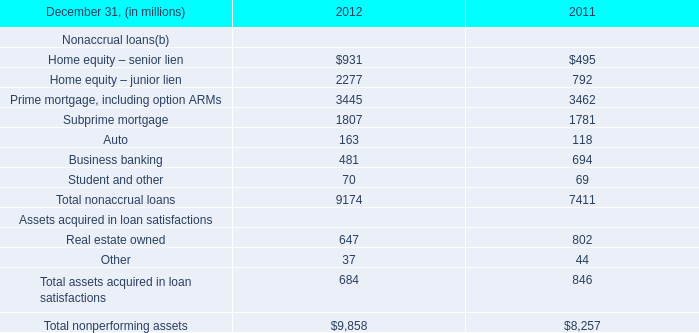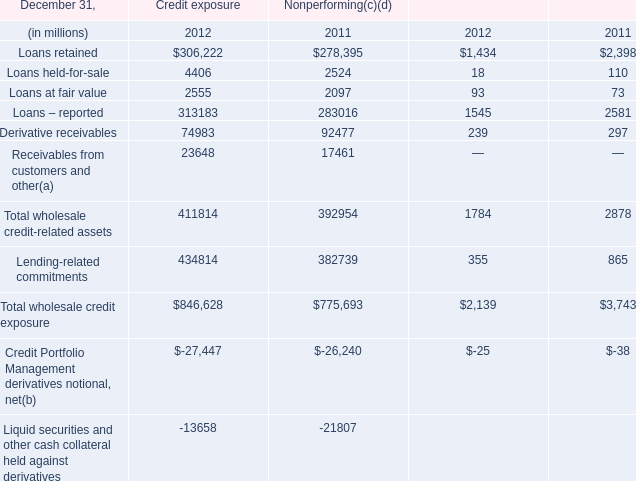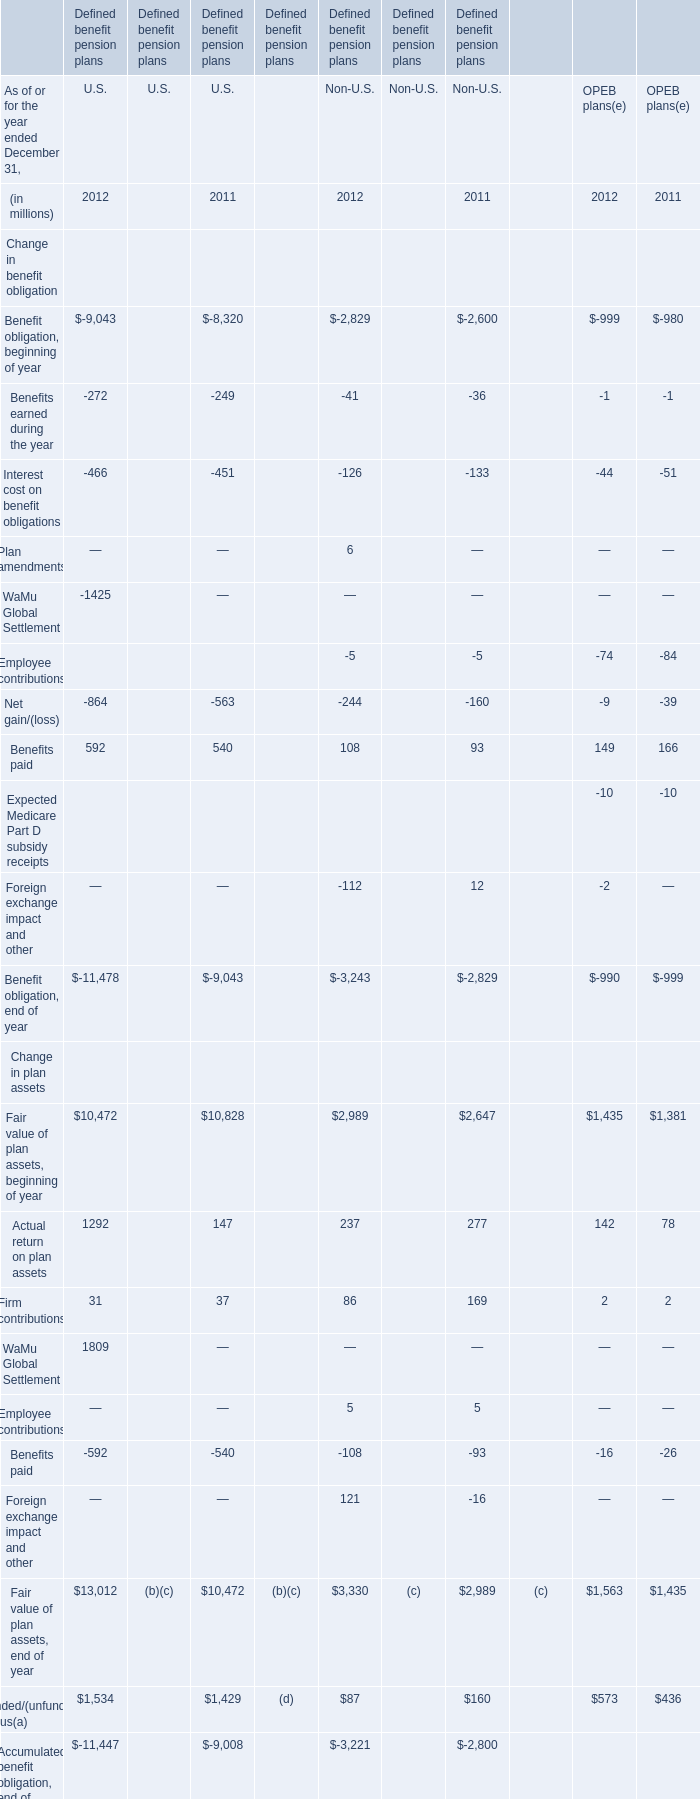What is the sum of Home equity – senior lien in 2012 and Benefits earned during the year in 2012 for U.S. (in million) 
Computations: (931 - 272)
Answer: 659.0. 